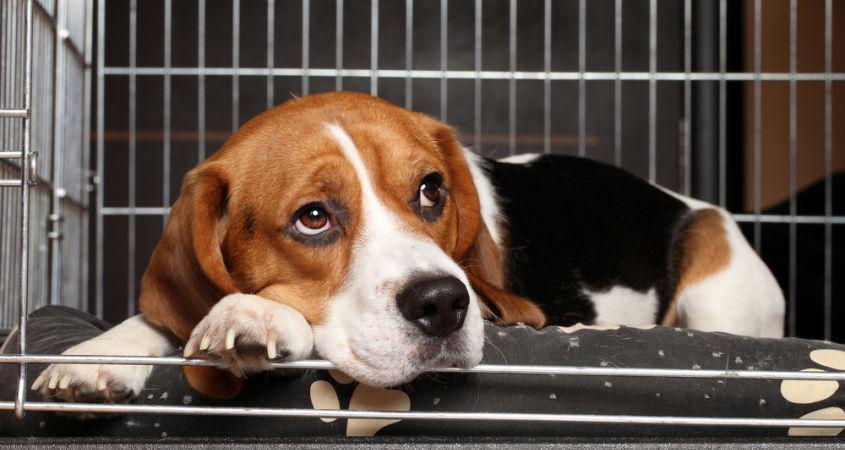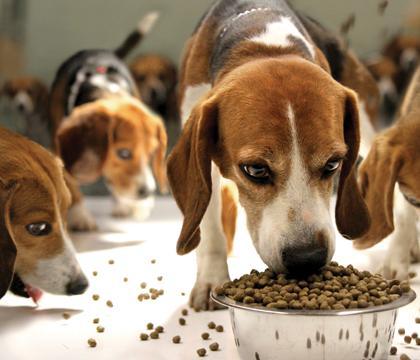The first image is the image on the left, the second image is the image on the right. Analyze the images presented: Is the assertion "At least one beagle is eating out of a bowl." valid? Answer yes or no. Yes. The first image is the image on the left, the second image is the image on the right. Given the left and right images, does the statement "An image shows at least one beagle dog eating from a bowl." hold true? Answer yes or no. Yes. 